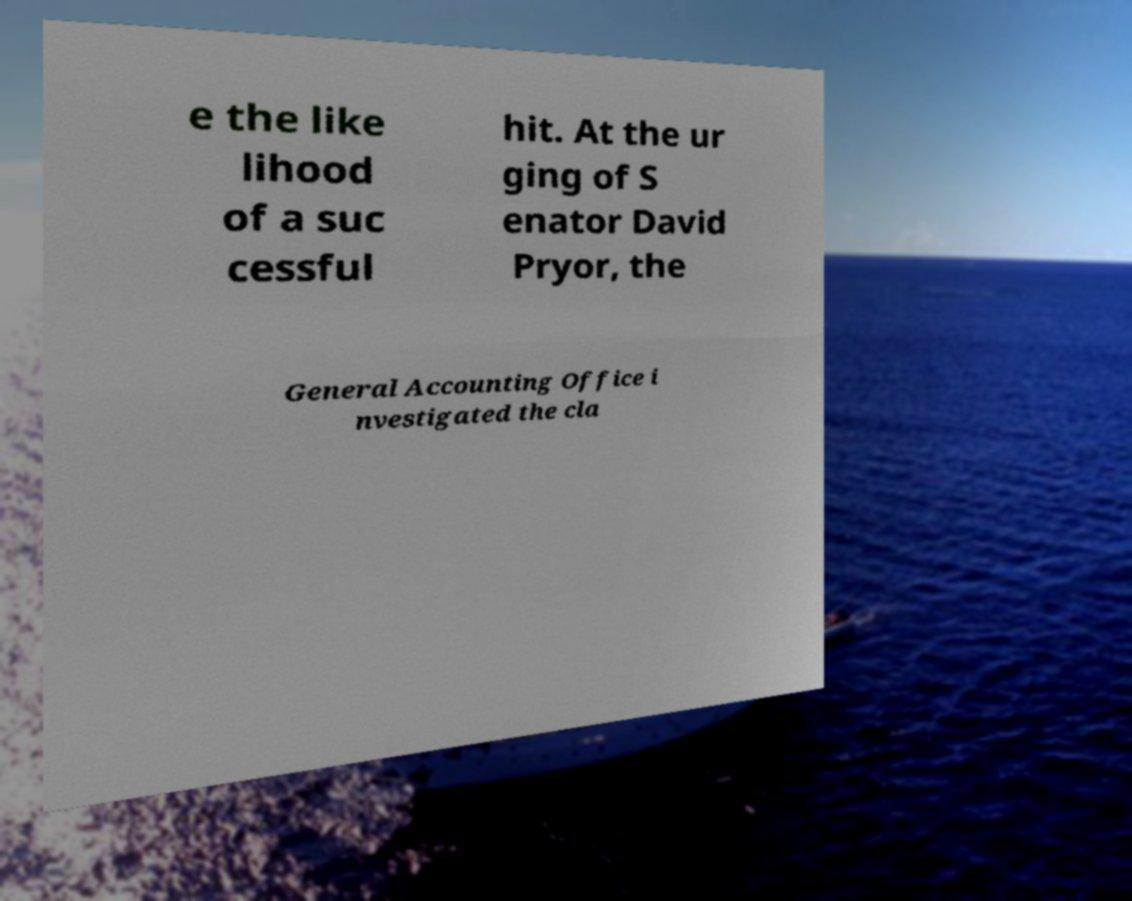There's text embedded in this image that I need extracted. Can you transcribe it verbatim? e the like lihood of a suc cessful hit. At the ur ging of S enator David Pryor, the General Accounting Office i nvestigated the cla 